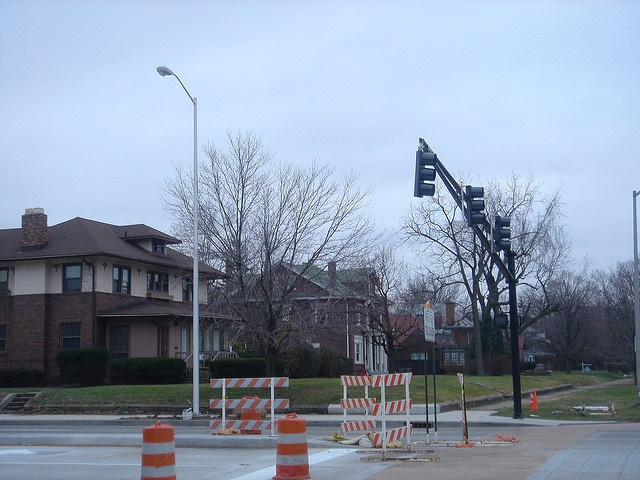Describe the objects in this image and their specific colors. I can see traffic light in lavender, navy, darkblue, gray, and blue tones, traffic light in lavender, navy, darkblue, black, and gray tones, and traffic light in lightblue, navy, black, gray, and darkblue tones in this image. 